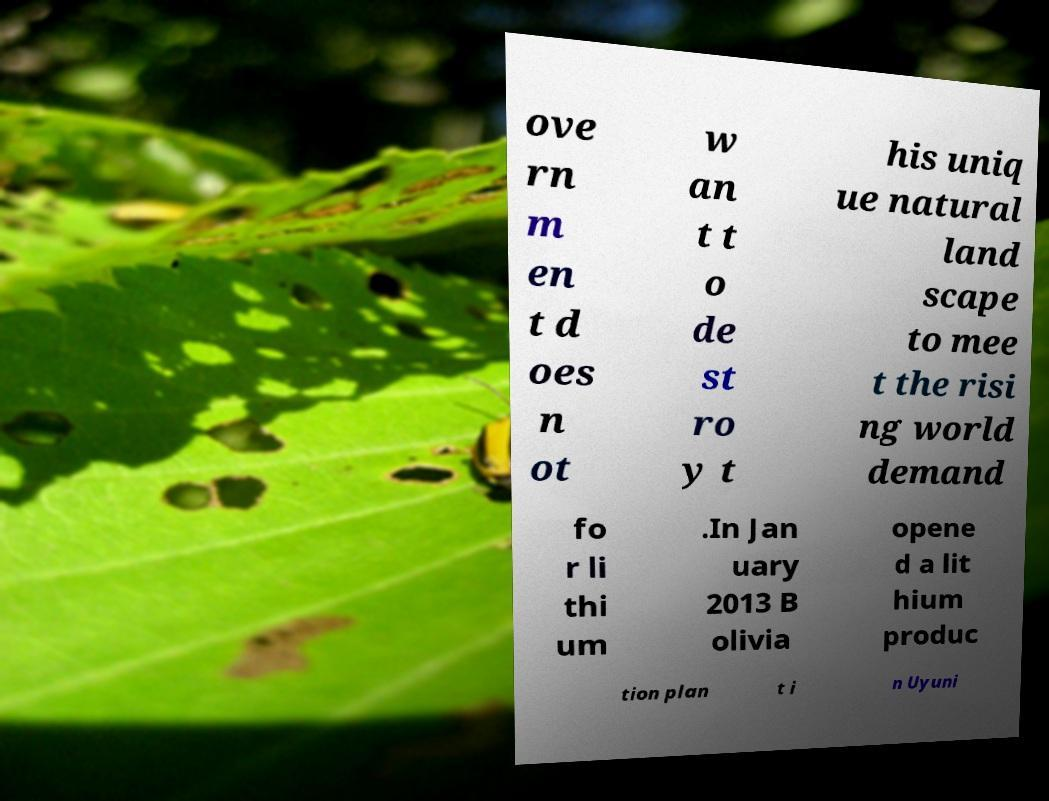For documentation purposes, I need the text within this image transcribed. Could you provide that? ove rn m en t d oes n ot w an t t o de st ro y t his uniq ue natural land scape to mee t the risi ng world demand fo r li thi um .In Jan uary 2013 B olivia opene d a lit hium produc tion plan t i n Uyuni 